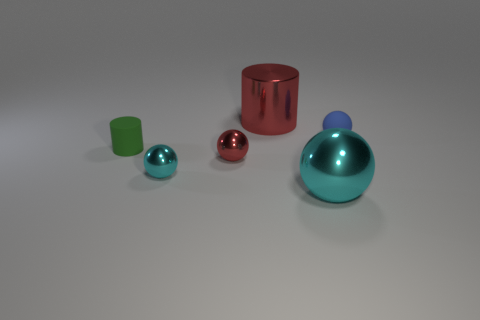Is there a small red metal object left of the red cylinder that is right of the matte object that is in front of the small blue rubber sphere?
Ensure brevity in your answer.  Yes. How many other things are there of the same color as the small rubber ball?
Your answer should be very brief. 0. How many objects are both behind the small cyan ball and right of the green matte object?
Offer a very short reply. 3. What is the shape of the small cyan object?
Keep it short and to the point. Sphere. What number of other things are the same material as the green cylinder?
Give a very brief answer. 1. There is a big thing to the left of the big thing that is in front of the sphere that is to the right of the large cyan object; what is its color?
Provide a short and direct response. Red. What is the material of the cyan sphere that is the same size as the red ball?
Your response must be concise. Metal. What number of objects are cylinders that are right of the red metal sphere or small cyan metallic balls?
Your answer should be compact. 2. Are any big brown blocks visible?
Your response must be concise. No. What is the large object behind the big ball made of?
Your answer should be very brief. Metal. 